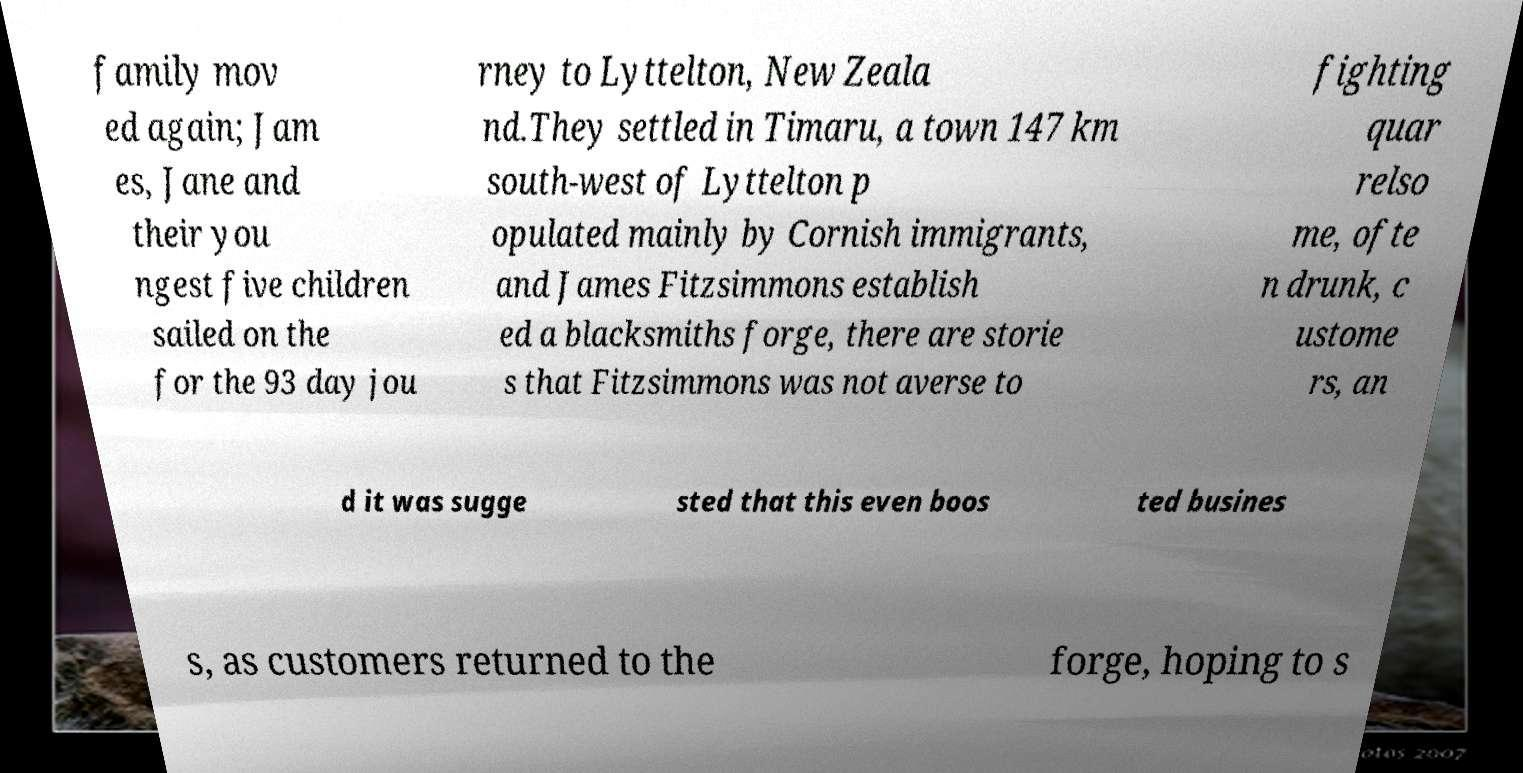For documentation purposes, I need the text within this image transcribed. Could you provide that? family mov ed again; Jam es, Jane and their you ngest five children sailed on the for the 93 day jou rney to Lyttelton, New Zeala nd.They settled in Timaru, a town 147 km south-west of Lyttelton p opulated mainly by Cornish immigrants, and James Fitzsimmons establish ed a blacksmiths forge, there are storie s that Fitzsimmons was not averse to fighting quar relso me, ofte n drunk, c ustome rs, an d it was sugge sted that this even boos ted busines s, as customers returned to the forge, hoping to s 